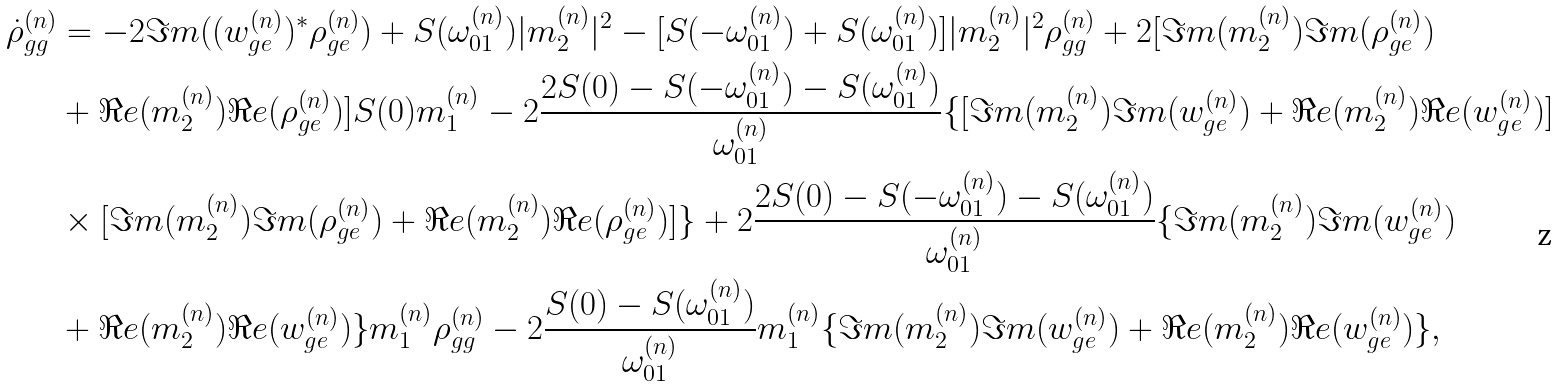<formula> <loc_0><loc_0><loc_500><loc_500>\dot { \rho } _ { g g } ^ { ( n ) } & = - 2 \Im m ( ( w _ { g e } ^ { ( n ) } ) ^ { * } \rho _ { g e } ^ { ( n ) } ) + S ( \omega _ { 0 1 } ^ { ( n ) } ) | m _ { 2 } ^ { ( n ) } | ^ { 2 } - [ S ( - \omega _ { 0 1 } ^ { ( n ) } ) + S ( \omega _ { 0 1 } ^ { ( n ) } ) ] | m _ { 2 } ^ { ( n ) } | ^ { 2 } \rho _ { g g } ^ { ( n ) } + 2 [ \Im m ( m _ { 2 } ^ { ( n ) } ) \Im m ( \rho _ { g e } ^ { ( n ) } ) \\ & + \Re e ( m _ { 2 } ^ { ( n ) } ) \Re e ( \rho _ { g e } ^ { ( n ) } ) ] S ( 0 ) m _ { 1 } ^ { ( n ) } - 2 \frac { 2 S ( 0 ) - S ( - \omega _ { 0 1 } ^ { ( n ) } ) - S ( \omega _ { 0 1 } ^ { ( n ) } ) } { \omega _ { 0 1 } ^ { ( n ) } } \{ [ \Im m ( m _ { 2 } ^ { ( n ) } ) \Im m ( w _ { g e } ^ { ( n ) } ) + \Re e ( m _ { 2 } ^ { ( n ) } ) \Re e ( w _ { g e } ^ { ( n ) } ) ] \\ & \times [ \Im m ( m _ { 2 } ^ { ( n ) } ) \Im m ( \rho _ { g e } ^ { ( n ) } ) + \Re e ( m _ { 2 } ^ { ( n ) } ) \Re e ( \rho _ { g e } ^ { ( n ) } ) ] \} + 2 \frac { 2 S ( 0 ) - S ( - \omega _ { 0 1 } ^ { ( n ) } ) - S ( \omega _ { 0 1 } ^ { ( n ) } ) } { \omega _ { 0 1 } ^ { ( n ) } } \{ \Im m ( m _ { 2 } ^ { ( n ) } ) \Im m ( w _ { g e } ^ { ( n ) } ) \\ & + \Re e ( m _ { 2 } ^ { ( n ) } ) \Re e ( w _ { g e } ^ { ( n ) } ) \} m _ { 1 } ^ { ( n ) } \rho _ { g g } ^ { ( n ) } - 2 \frac { S ( 0 ) - S ( \omega _ { 0 1 } ^ { ( n ) } ) } { \omega _ { 0 1 } ^ { ( n ) } } m _ { 1 } ^ { ( n ) } \{ \Im m ( m _ { 2 } ^ { ( n ) } ) \Im m ( w _ { g e } ^ { ( n ) } ) + \Re e ( m _ { 2 } ^ { ( n ) } ) \Re e ( w _ { g e } ^ { ( n ) } ) \} ,</formula> 